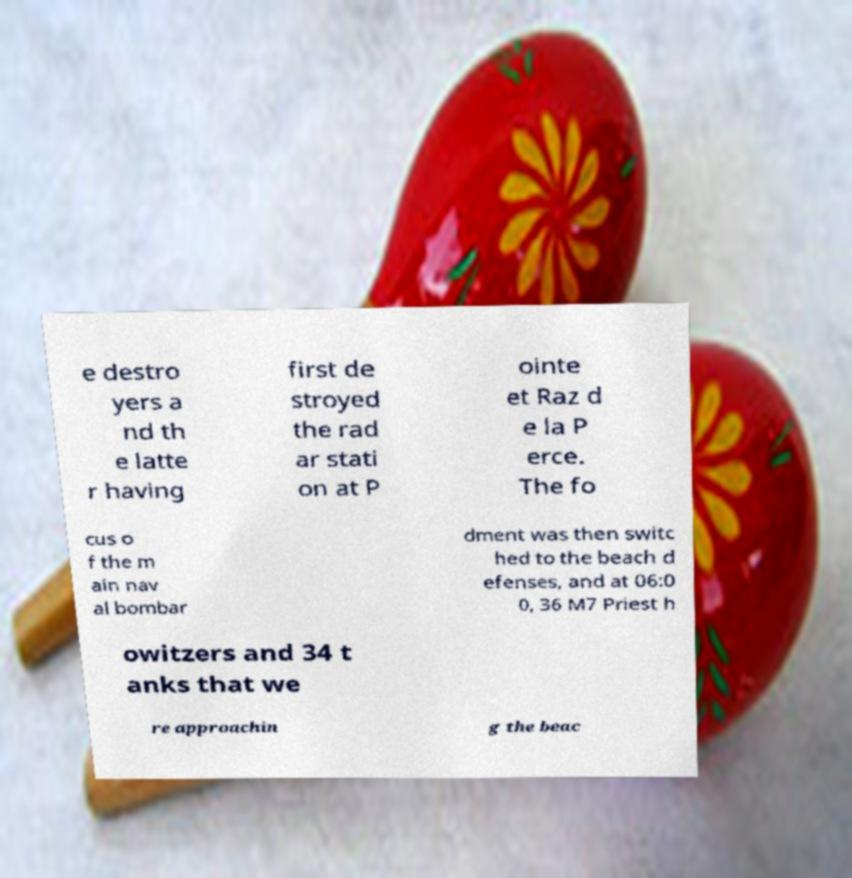Can you read and provide the text displayed in the image?This photo seems to have some interesting text. Can you extract and type it out for me? e destro yers a nd th e latte r having first de stroyed the rad ar stati on at P ointe et Raz d e la P erce. The fo cus o f the m ain nav al bombar dment was then switc hed to the beach d efenses, and at 06:0 0, 36 M7 Priest h owitzers and 34 t anks that we re approachin g the beac 